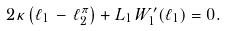<formula> <loc_0><loc_0><loc_500><loc_500>2 \kappa \left ( \ell _ { 1 } \, - \, \ell _ { 2 } ^ { \pi } \right ) + L _ { 1 } \, W _ { 1 } ^ { \prime } ( \ell _ { 1 } ) = 0 .</formula> 